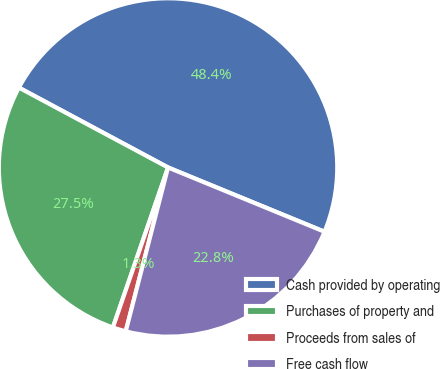Convert chart to OTSL. <chart><loc_0><loc_0><loc_500><loc_500><pie_chart><fcel>Cash provided by operating<fcel>Purchases of property and<fcel>Proceeds from sales of<fcel>Free cash flow<nl><fcel>48.38%<fcel>27.54%<fcel>1.26%<fcel>22.82%<nl></chart> 